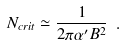Convert formula to latex. <formula><loc_0><loc_0><loc_500><loc_500>N _ { c r i t } \simeq \frac { 1 } { 2 \pi \alpha ^ { \prime } B ^ { 2 } } \ .</formula> 